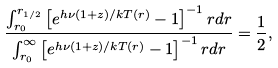<formula> <loc_0><loc_0><loc_500><loc_500>\frac { \int _ { r _ { 0 } } ^ { r _ { 1 / 2 } } \left [ e ^ { h \nu ( 1 + z ) / k T ( r ) } - 1 \right ] ^ { - 1 } r d r } { \int _ { r _ { 0 } } ^ { \infty } \left [ e ^ { h \nu ( 1 + z ) / k T ( r ) } - 1 \right ] ^ { - 1 } r d r } = \frac { 1 } { 2 } ,</formula> 